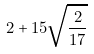Convert formula to latex. <formula><loc_0><loc_0><loc_500><loc_500>2 + 1 5 \sqrt { \frac { 2 } { 1 7 } }</formula> 